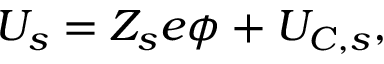<formula> <loc_0><loc_0><loc_500><loc_500>\begin{array} { r } { U _ { s } = Z _ { s } e \phi + U _ { C , s } , } \end{array}</formula> 